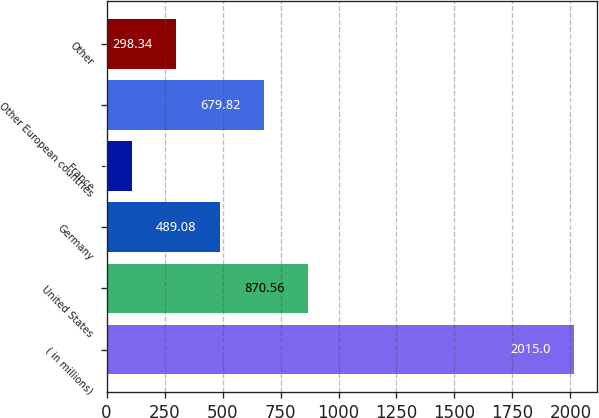<chart> <loc_0><loc_0><loc_500><loc_500><bar_chart><fcel>( in millions)<fcel>United States<fcel>Germany<fcel>France<fcel>Other European countries<fcel>Other<nl><fcel>2015<fcel>870.56<fcel>489.08<fcel>107.6<fcel>679.82<fcel>298.34<nl></chart> 